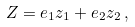<formula> <loc_0><loc_0><loc_500><loc_500>Z = e _ { 1 } z _ { 1 } + e _ { 2 } z _ { 2 } \, ,</formula> 